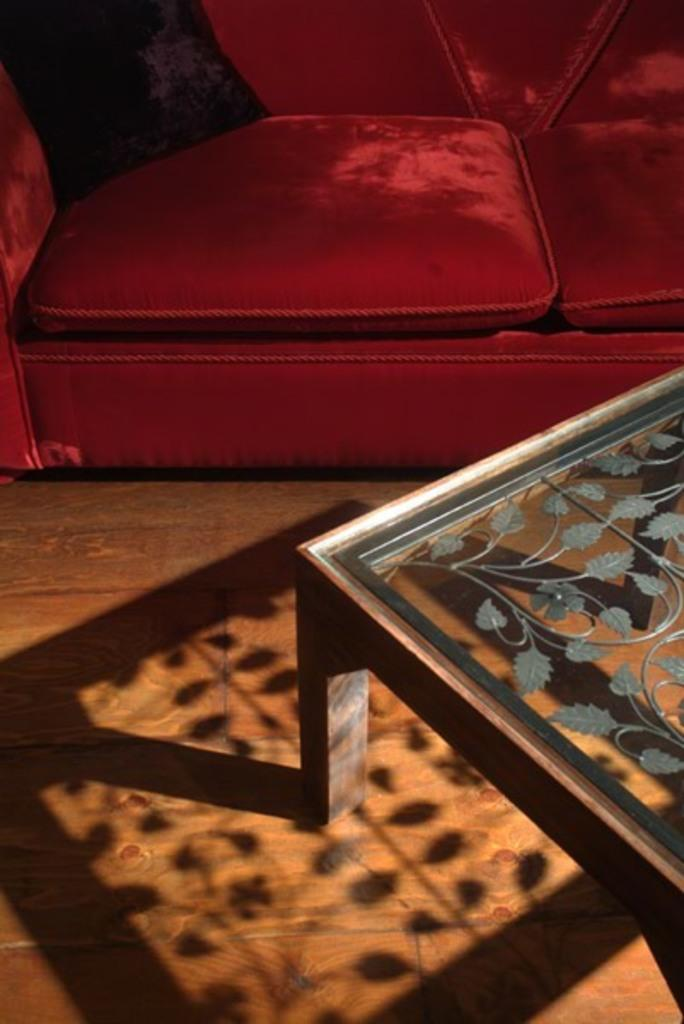What type of sofa is in the image? There is a red color sofa in the image. What is the material of the table in the image? The table in the image is made of glass. Where is the glass table located in the image? The glass table is on the floor. How many times does the lead get crushed in the image? There is no lead present in the image, so it cannot be crushed. 